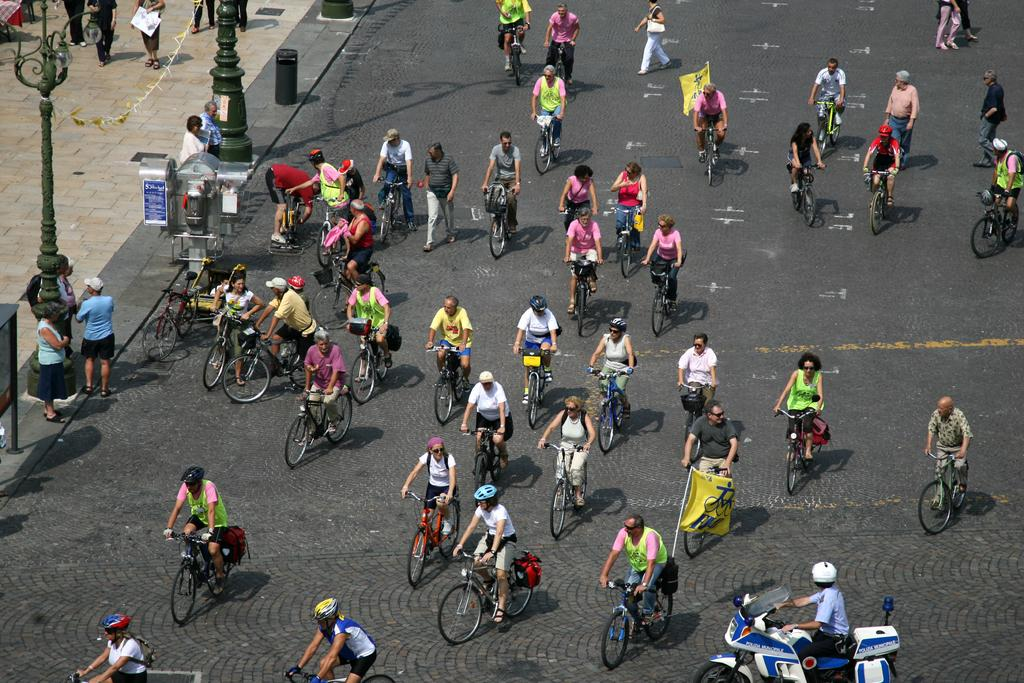What are the people in the image doing? There are people riding bicycles in the image. What else can be seen in the image besides the people on bicycles? There are poles visible in the image. What is on the left side of the image? There is a walkway on the left side of the image. What color is the blood on the girls' faces in the image? There are no girls or blood present in the image; it features people riding bicycles and poles. 